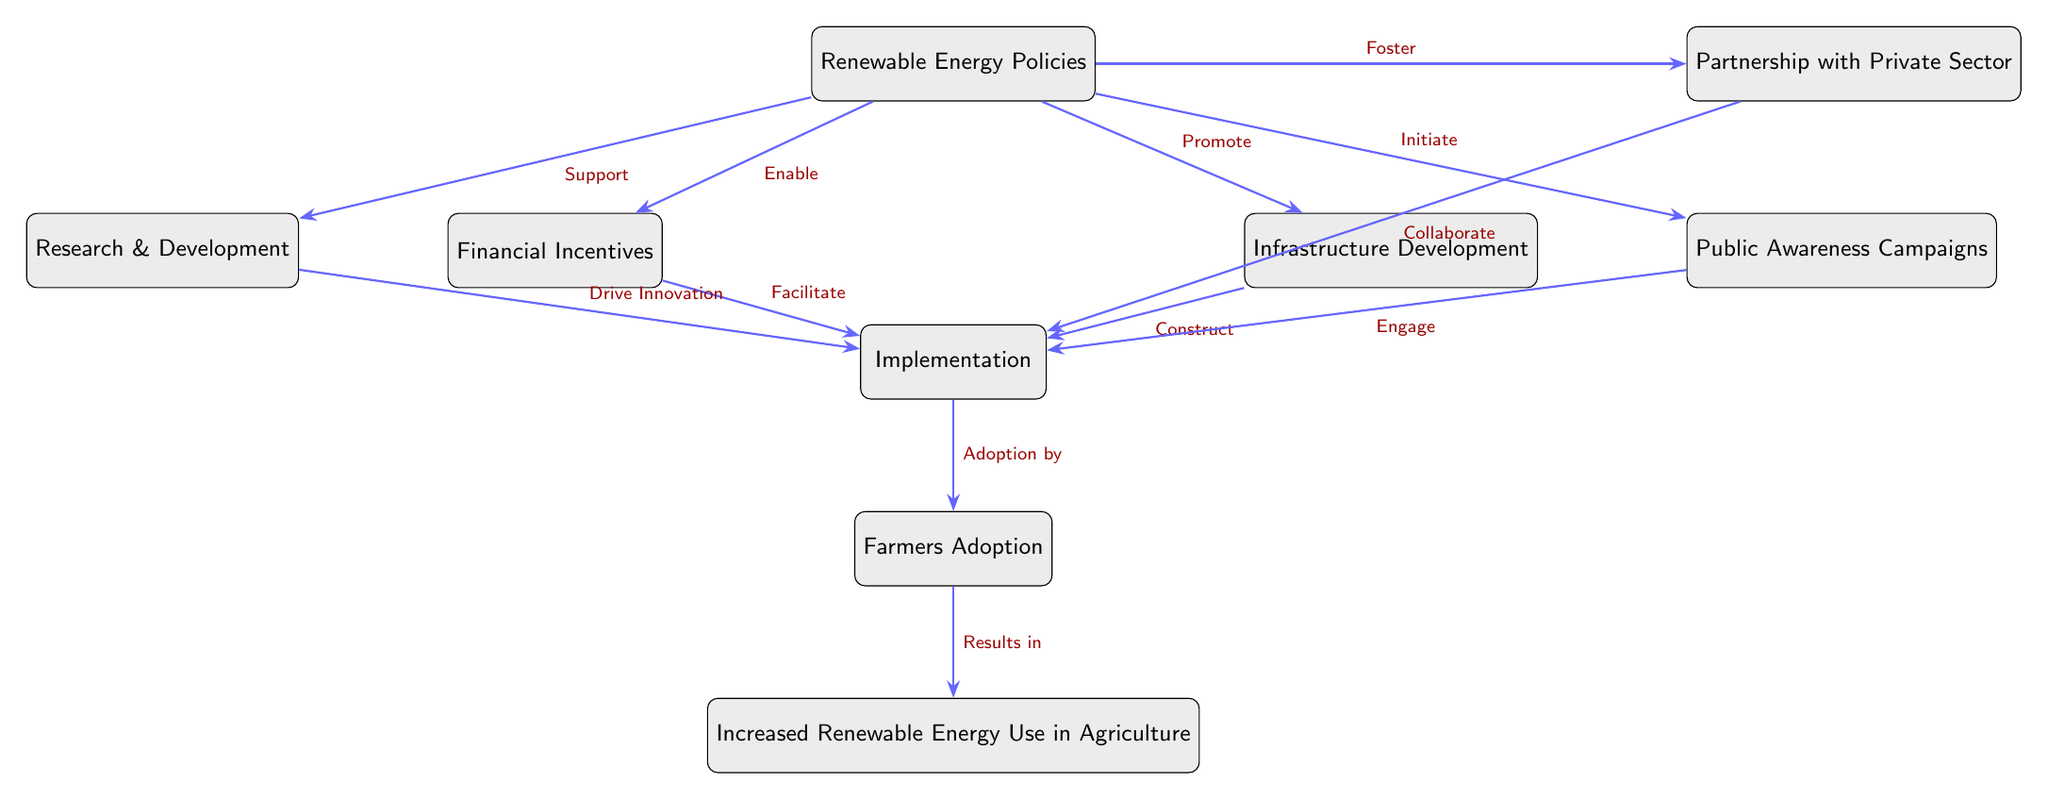What is the starting point of the flow in the diagram? The starting point is the node labeled "Renewable Energy Policies", which is at the top of the diagram and initiates the flow to other components.
Answer: Renewable Energy Policies How many nodes are present in the diagram? By counting each individual box, including the starting point and the endpoint, the total number of nodes is found to be nine.
Answer: 9 What action is associated with the connection from "Renewable Energy Policies" to "Financial Incentives"? The action that connects these two nodes is denoted by the label "Enable", indicating that the Renewable Energy Policies enable the Financial Incentives.
Answer: Enable Which two nodes are connected by the action "Collaborate"? The nodes connected by "Collaborate" are "Partnership with Private Sector" and "Implementation", demonstrating their relationship in the adoption process.
Answer: Partnership with Private Sector, Implementation What is the final outcome described in the diagram? The final outcome is represented by the last node labeled "Increased Renewable Energy Use in Agriculture," which indicates the intended result of the previous actions.
Answer: Increased Renewable Energy Use in Agriculture What relationship does "Infrastructure Development" have with "Implementation"? "Infrastructure Development" is connected to "Implementation" via the action "Construct," meaning it plays a significant role in the construction needed to facilitate implementation.
Answer: Construct Which node acts as a connector between several nodes including "Financial Incentives" and "Infrastructure Development"? The node "Renewable Energy Policies" acts as the connector, linking multiple nodes and enabling various actions related to renewable energy adoption.
Answer: Renewable Energy Policies What facilitates the transition from "Financial Incentives" to "Implementation"? The transition is facilitated by the action "Facilitate," indicating that financial incentives are crucial for enabling the implementation phase.
Answer: Facilitate How does "Public Awareness Campaigns" contribute to the process? "Public Awareness Campaigns" is associated with the action "Engage," which means it plays an active role in engaging stakeholders in the implementation phase.
Answer: Engage 